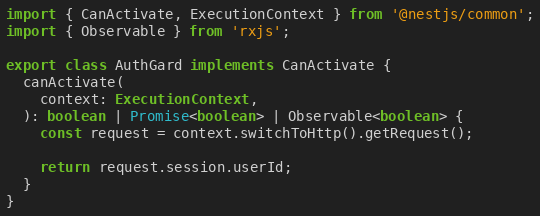<code> <loc_0><loc_0><loc_500><loc_500><_TypeScript_>import { CanActivate, ExecutionContext } from '@nestjs/common';
import { Observable } from 'rxjs';

export class AuthGard implements CanActivate {
  canActivate(
    context: ExecutionContext,
  ): boolean | Promise<boolean> | Observable<boolean> {
    const request = context.switchToHttp().getRequest();

    return request.session.userId;
  }
}
</code> 